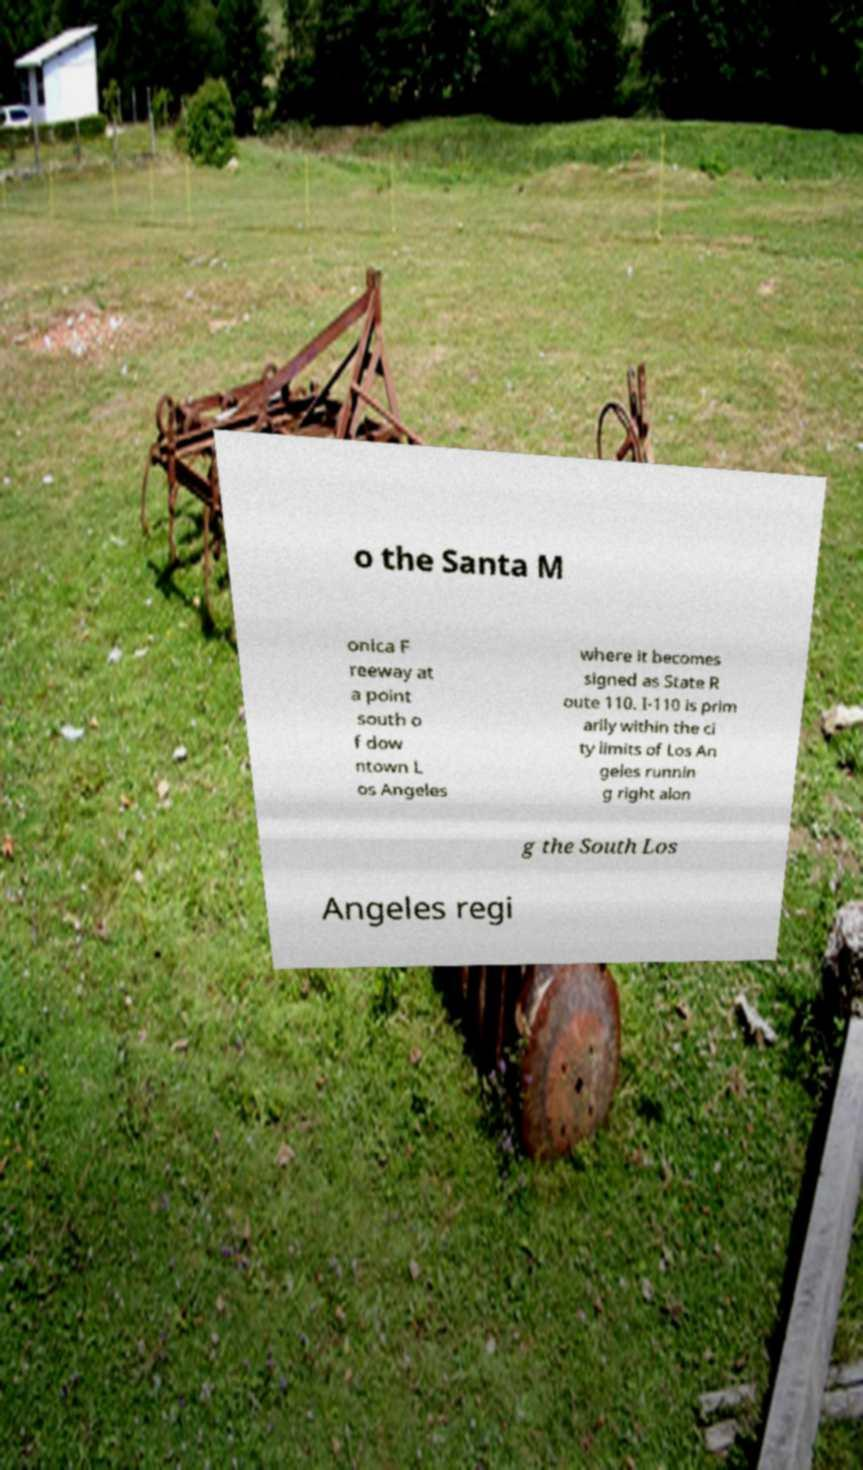What messages or text are displayed in this image? I need them in a readable, typed format. o the Santa M onica F reeway at a point south o f dow ntown L os Angeles where it becomes signed as State R oute 110. I-110 is prim arily within the ci ty limits of Los An geles runnin g right alon g the South Los Angeles regi 